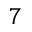Convert formula to latex. <formula><loc_0><loc_0><loc_500><loc_500>7</formula> 